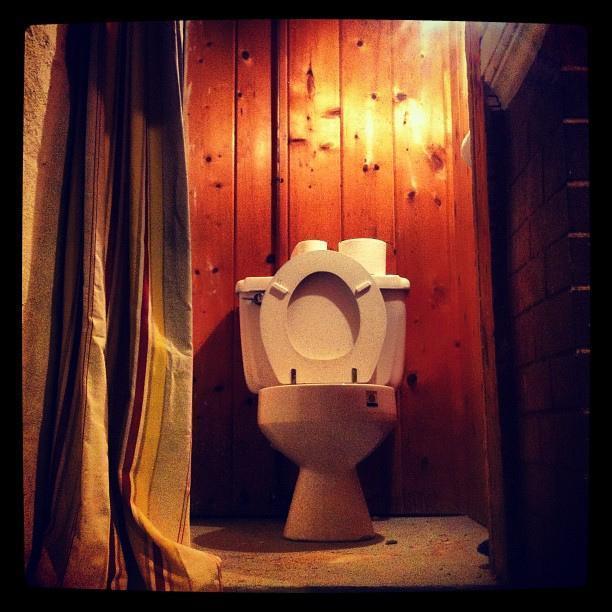How many of the people in the picture are wearing pants?
Give a very brief answer. 0. 